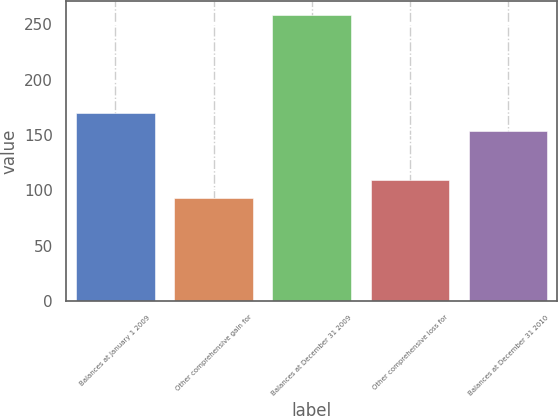Convert chart. <chart><loc_0><loc_0><loc_500><loc_500><bar_chart><fcel>Balances at January 1 2009<fcel>Other comprehensive gain for<fcel>Balances at December 31 2009<fcel>Other comprehensive loss for<fcel>Balances at December 31 2010<nl><fcel>169.98<fcel>93.2<fcel>258<fcel>109.68<fcel>153.5<nl></chart> 